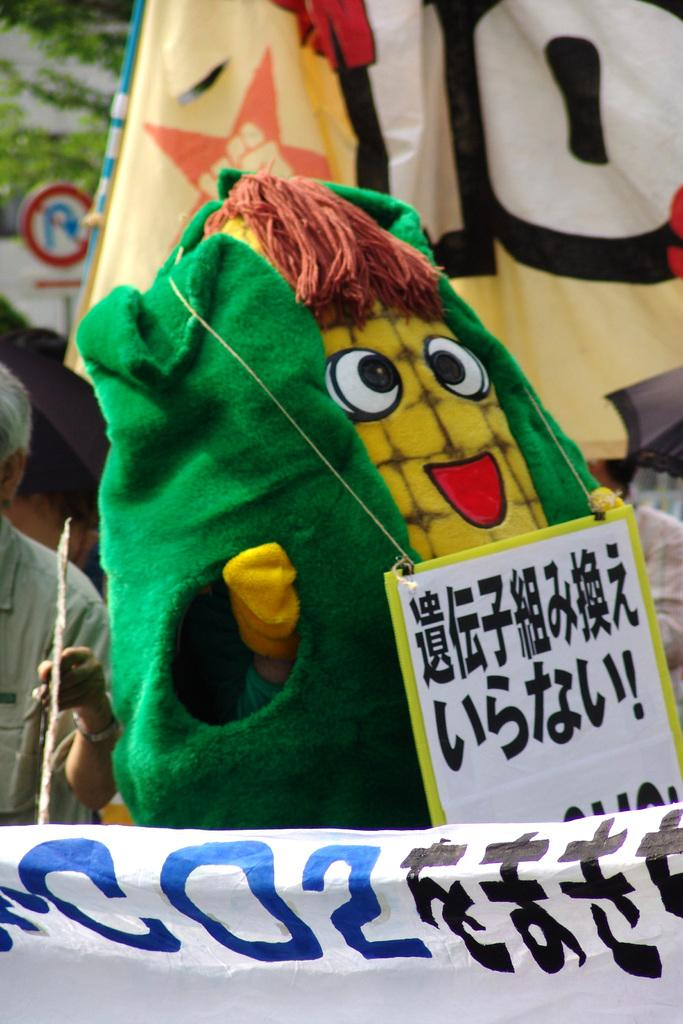What object can be seen in the image that is typically used for play? There is a toy in the image. Can you describe the person in the image? There is a person standing in the image. What type of decoration is present in the image? There is a banner in the image. What can be seen in the background of the image? There is a sign board in the background of the image. Can you tell me how many rabbits are sitting on the stove in the image? There are no rabbits or stoves present in the image. What type of winter clothing is the person wearing in the image? There is no reference to winter or clothing in the image; it only shows a person standing with a toy and a banner. 